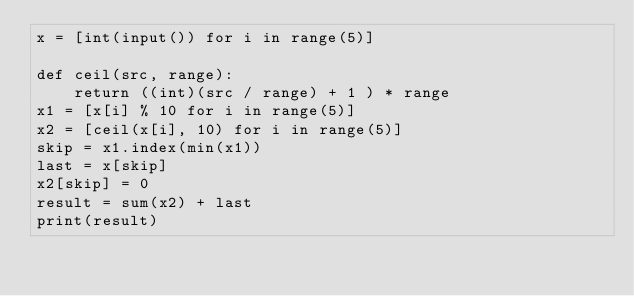Convert code to text. <code><loc_0><loc_0><loc_500><loc_500><_Python_>x = [int(input()) for i in range(5)]

def ceil(src, range):
    return ((int)(src / range) + 1 ) * range
x1 = [x[i] % 10 for i in range(5)]
x2 = [ceil(x[i], 10) for i in range(5)]
skip = x1.index(min(x1))
last = x[skip]
x2[skip] = 0
result = sum(x2) + last
print(result)</code> 